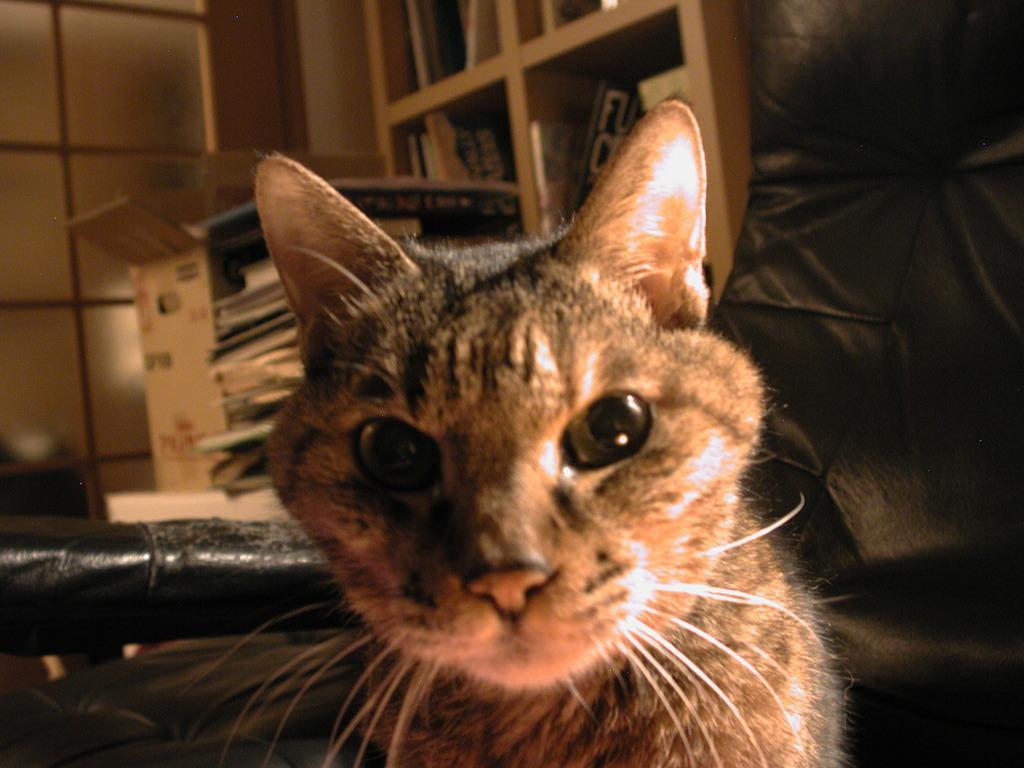How would you summarize this image in a sentence or two? In this image we can see a cat. In the background there are books arranged in the shelves, cardboard carton and a pile of papers. 